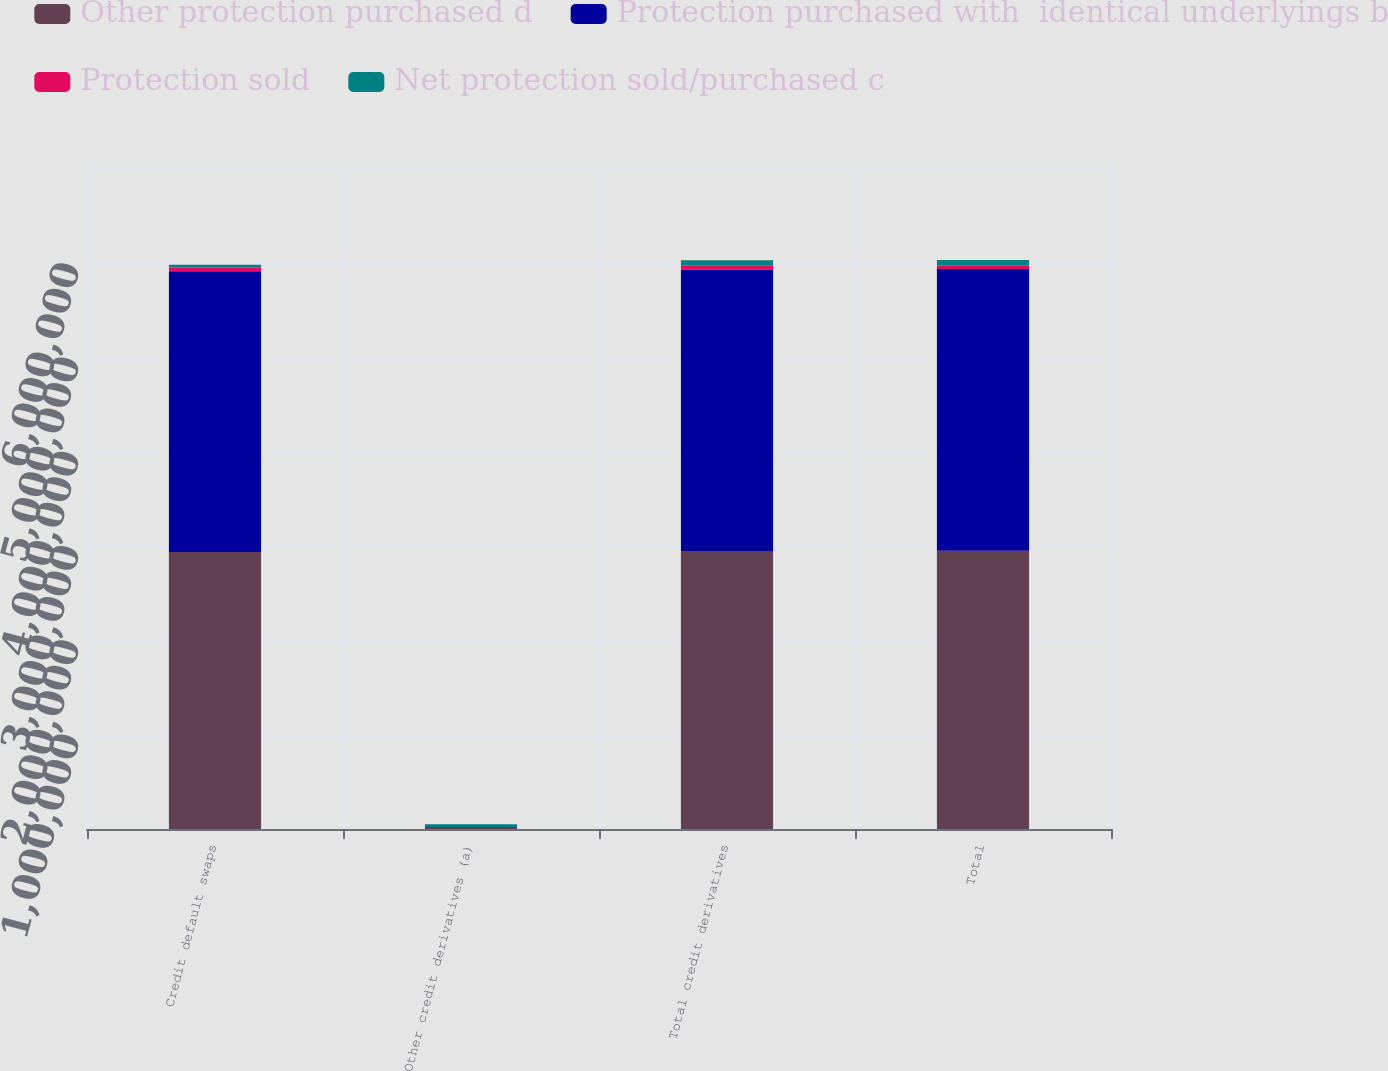Convert chart to OTSL. <chart><loc_0><loc_0><loc_500><loc_500><stacked_bar_chart><ecel><fcel>Credit default swaps<fcel>Other credit derivatives (a)<fcel>Total credit derivatives<fcel>Total<nl><fcel>Other protection purchased d<fcel>2.93744e+06<fcel>10575<fcel>2.94802e+06<fcel>2.95205e+06<nl><fcel>Protection purchased with  identical underlyings b<fcel>2.97804e+06<fcel>9290<fcel>2.98733e+06<fcel>2.98733e+06<nl><fcel>Protection sold<fcel>40602<fcel>1285<fcel>39317<fcel>35286<nl><fcel>Net protection sold/purchased c<fcel>28064<fcel>30473<fcel>58537<fcel>60265<nl></chart> 